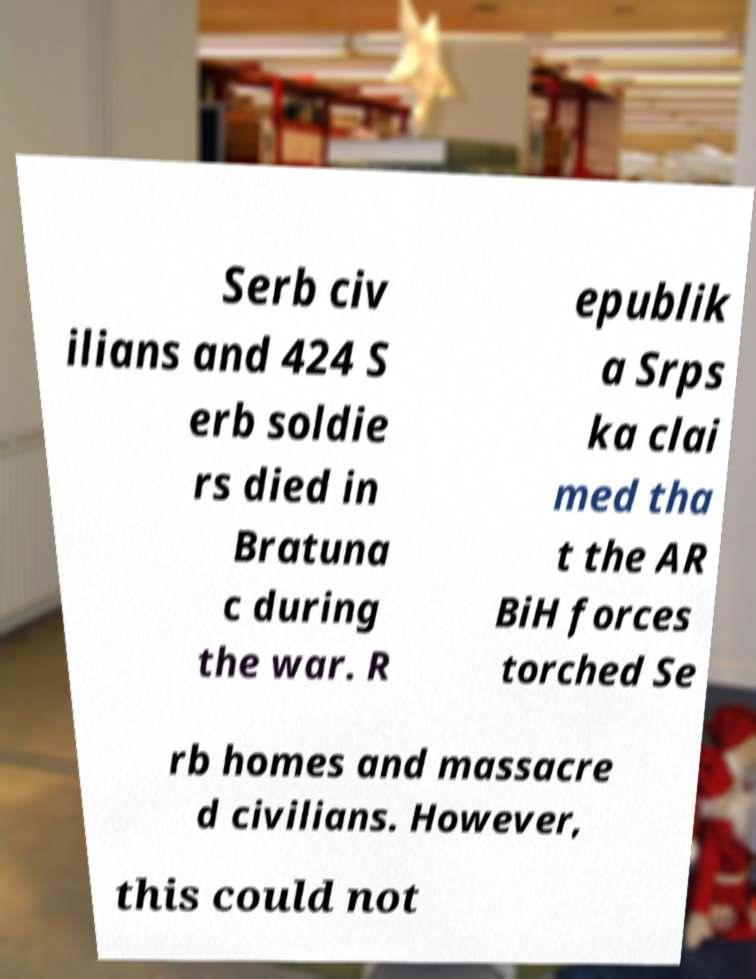Please read and relay the text visible in this image. What does it say? Serb civ ilians and 424 S erb soldie rs died in Bratuna c during the war. R epublik a Srps ka clai med tha t the AR BiH forces torched Se rb homes and massacre d civilians. However, this could not 